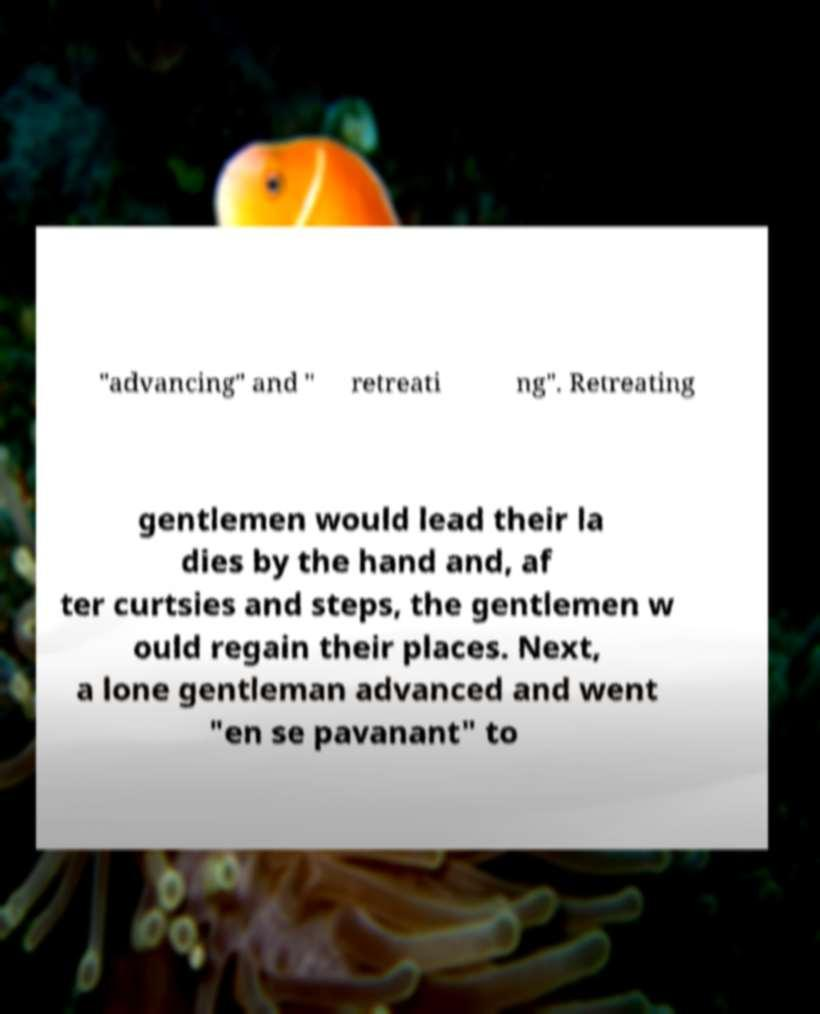Please read and relay the text visible in this image. What does it say? "advancing" and " retreati ng". Retreating gentlemen would lead their la dies by the hand and, af ter curtsies and steps, the gentlemen w ould regain their places. Next, a lone gentleman advanced and went "en se pavanant" to 